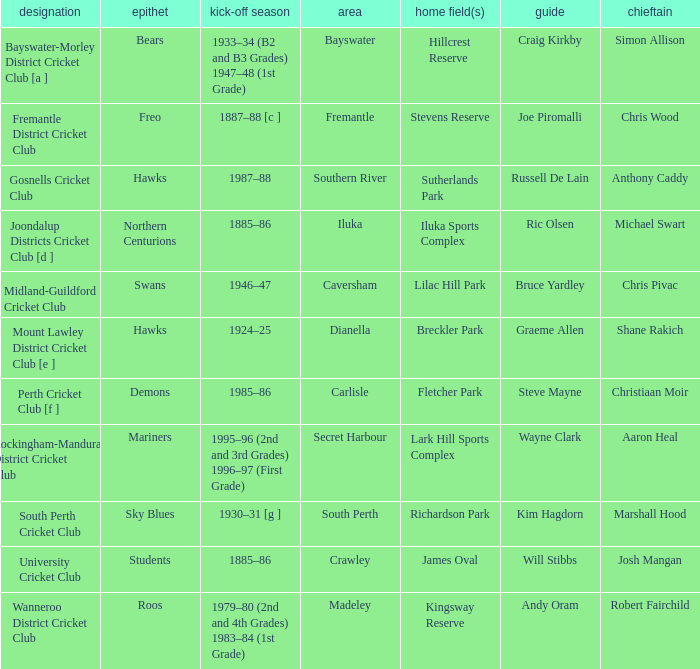For location Caversham, what is the name of the captain? Chris Pivac. 